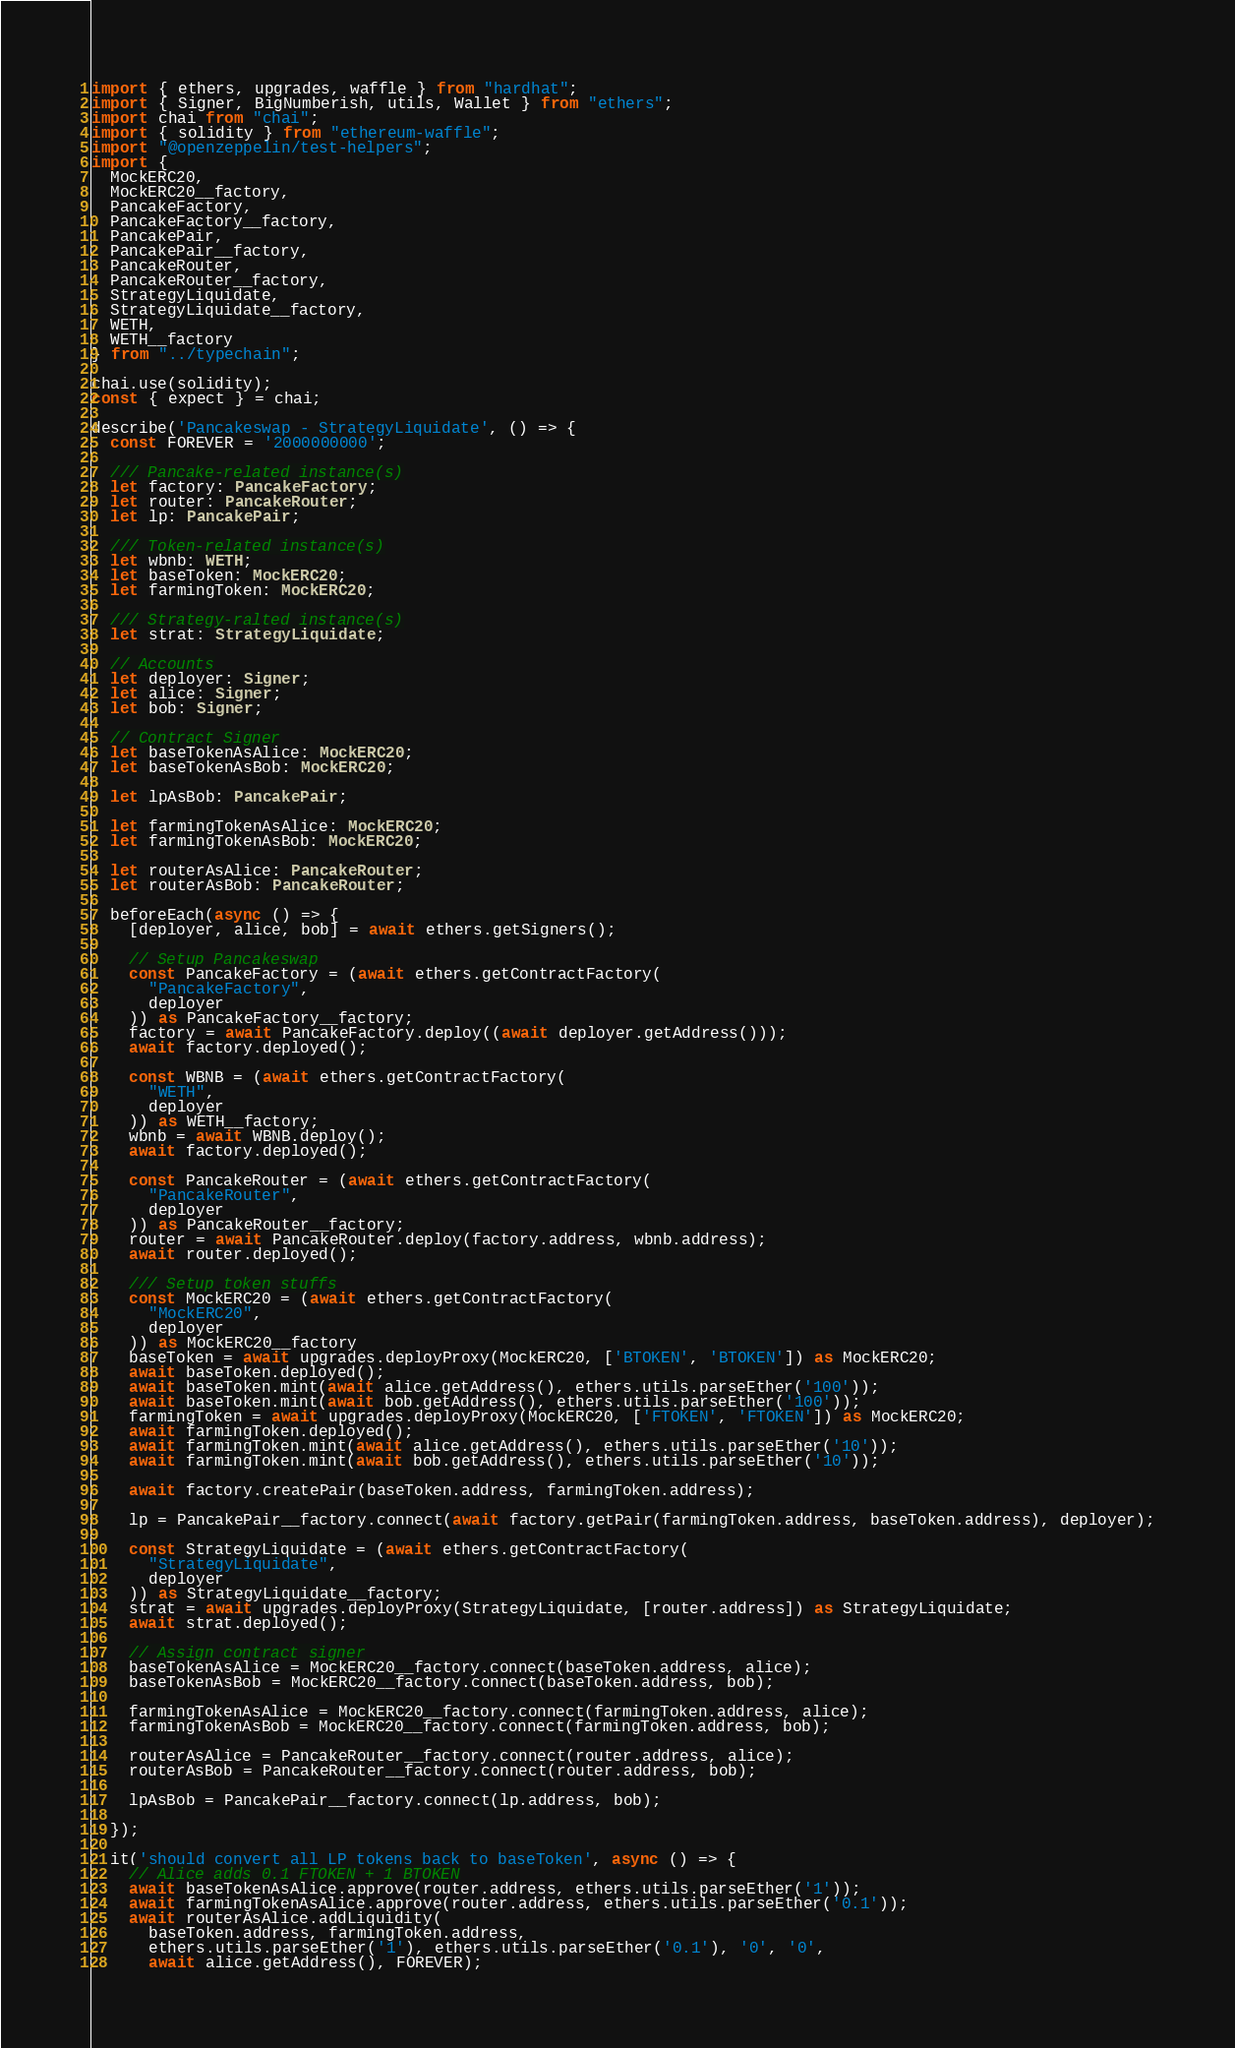<code> <loc_0><loc_0><loc_500><loc_500><_TypeScript_>import { ethers, upgrades, waffle } from "hardhat";
import { Signer, BigNumberish, utils, Wallet } from "ethers";
import chai from "chai";
import { solidity } from "ethereum-waffle";
import "@openzeppelin/test-helpers";
import {
  MockERC20,
  MockERC20__factory,
  PancakeFactory,
  PancakeFactory__factory,
  PancakePair,
  PancakePair__factory,
  PancakeRouter,
  PancakeRouter__factory,
  StrategyLiquidate,
  StrategyLiquidate__factory,
  WETH,
  WETH__factory
} from "../typechain";

chai.use(solidity);
const { expect } = chai;

describe('Pancakeswap - StrategyLiquidate', () => {
  const FOREVER = '2000000000';

  /// Pancake-related instance(s)
  let factory: PancakeFactory;
  let router: PancakeRouter;
  let lp: PancakePair;

  /// Token-related instance(s)
  let wbnb: WETH;
  let baseToken: MockERC20;
  let farmingToken: MockERC20;

  /// Strategy-ralted instance(s)
  let strat: StrategyLiquidate;

  // Accounts
  let deployer: Signer;
  let alice: Signer;
  let bob: Signer;

  // Contract Signer
  let baseTokenAsAlice: MockERC20;
  let baseTokenAsBob: MockERC20;

  let lpAsBob: PancakePair;

  let farmingTokenAsAlice: MockERC20;
  let farmingTokenAsBob: MockERC20;

  let routerAsAlice: PancakeRouter;
  let routerAsBob: PancakeRouter;

  beforeEach(async () => {
    [deployer, alice, bob] = await ethers.getSigners();

    // Setup Pancakeswap
    const PancakeFactory = (await ethers.getContractFactory(
      "PancakeFactory",
      deployer
    )) as PancakeFactory__factory;
    factory = await PancakeFactory.deploy((await deployer.getAddress()));
    await factory.deployed();

    const WBNB = (await ethers.getContractFactory(
      "WETH",
      deployer
    )) as WETH__factory;
    wbnb = await WBNB.deploy();
    await factory.deployed();

    const PancakeRouter = (await ethers.getContractFactory(
      "PancakeRouter",
      deployer
    )) as PancakeRouter__factory;
    router = await PancakeRouter.deploy(factory.address, wbnb.address);
    await router.deployed();

    /// Setup token stuffs
    const MockERC20 = (await ethers.getContractFactory(
      "MockERC20",
      deployer
    )) as MockERC20__factory
    baseToken = await upgrades.deployProxy(MockERC20, ['BTOKEN', 'BTOKEN']) as MockERC20;
    await baseToken.deployed();
    await baseToken.mint(await alice.getAddress(), ethers.utils.parseEther('100'));
    await baseToken.mint(await bob.getAddress(), ethers.utils.parseEther('100'));
    farmingToken = await upgrades.deployProxy(MockERC20, ['FTOKEN', 'FTOKEN']) as MockERC20;
    await farmingToken.deployed();
    await farmingToken.mint(await alice.getAddress(), ethers.utils.parseEther('10'));
    await farmingToken.mint(await bob.getAddress(), ethers.utils.parseEther('10'));

    await factory.createPair(baseToken.address, farmingToken.address);

    lp = PancakePair__factory.connect(await factory.getPair(farmingToken.address, baseToken.address), deployer);

    const StrategyLiquidate = (await ethers.getContractFactory(
      "StrategyLiquidate",
      deployer
    )) as StrategyLiquidate__factory;
    strat = await upgrades.deployProxy(StrategyLiquidate, [router.address]) as StrategyLiquidate;
    await strat.deployed();

    // Assign contract signer
    baseTokenAsAlice = MockERC20__factory.connect(baseToken.address, alice);
    baseTokenAsBob = MockERC20__factory.connect(baseToken.address, bob);

    farmingTokenAsAlice = MockERC20__factory.connect(farmingToken.address, alice);
    farmingTokenAsBob = MockERC20__factory.connect(farmingToken.address, bob);

    routerAsAlice = PancakeRouter__factory.connect(router.address, alice);
    routerAsBob = PancakeRouter__factory.connect(router.address, bob);

    lpAsBob = PancakePair__factory.connect(lp.address, bob);

  });

  it('should convert all LP tokens back to baseToken', async () => {
    // Alice adds 0.1 FTOKEN + 1 BTOKEN
    await baseTokenAsAlice.approve(router.address, ethers.utils.parseEther('1'));
    await farmingTokenAsAlice.approve(router.address, ethers.utils.parseEther('0.1'));
    await routerAsAlice.addLiquidity(
      baseToken.address, farmingToken.address,
      ethers.utils.parseEther('1'), ethers.utils.parseEther('0.1'), '0', '0',
      await alice.getAddress(), FOREVER);
</code> 